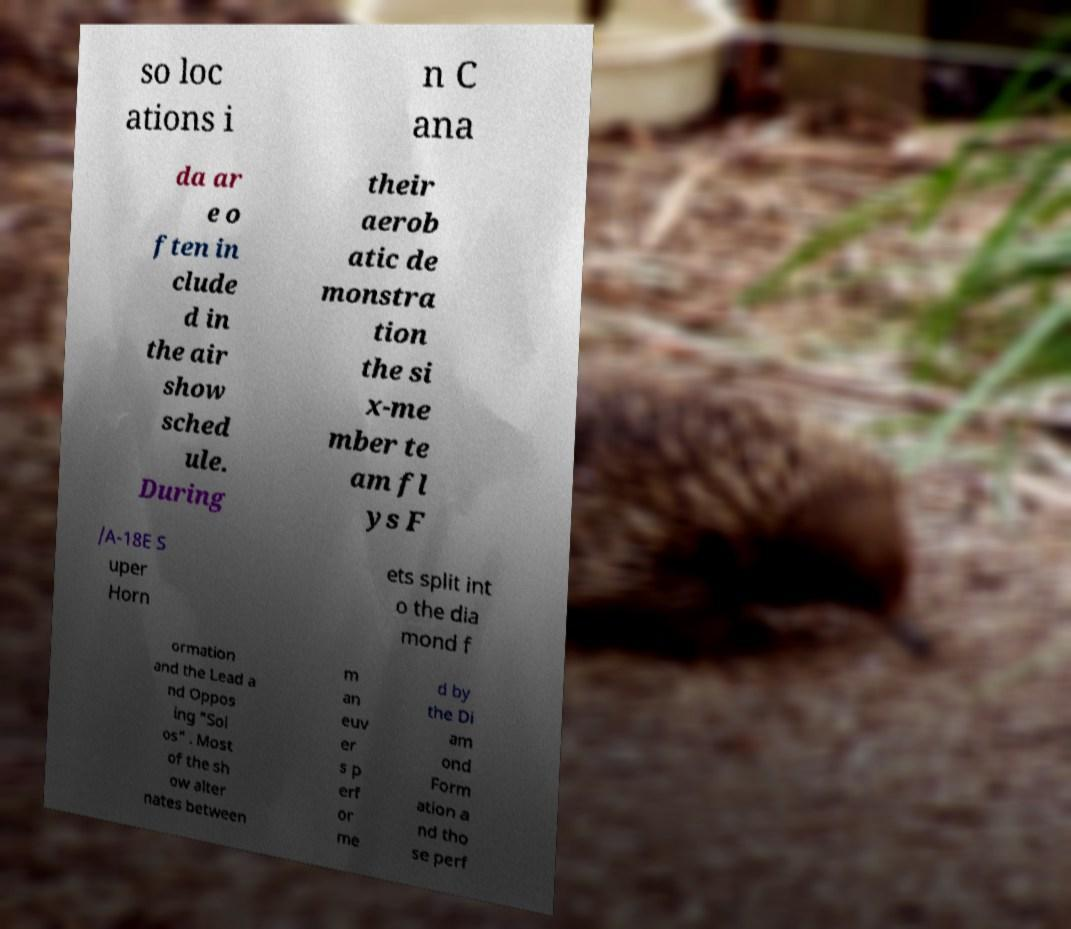For documentation purposes, I need the text within this image transcribed. Could you provide that? so loc ations i n C ana da ar e o ften in clude d in the air show sched ule. During their aerob atic de monstra tion the si x-me mber te am fl ys F /A-18E S uper Horn ets split int o the dia mond f ormation and the Lead a nd Oppos ing "Sol os" . Most of the sh ow alter nates between m an euv er s p erf or me d by the Di am ond Form ation a nd tho se perf 